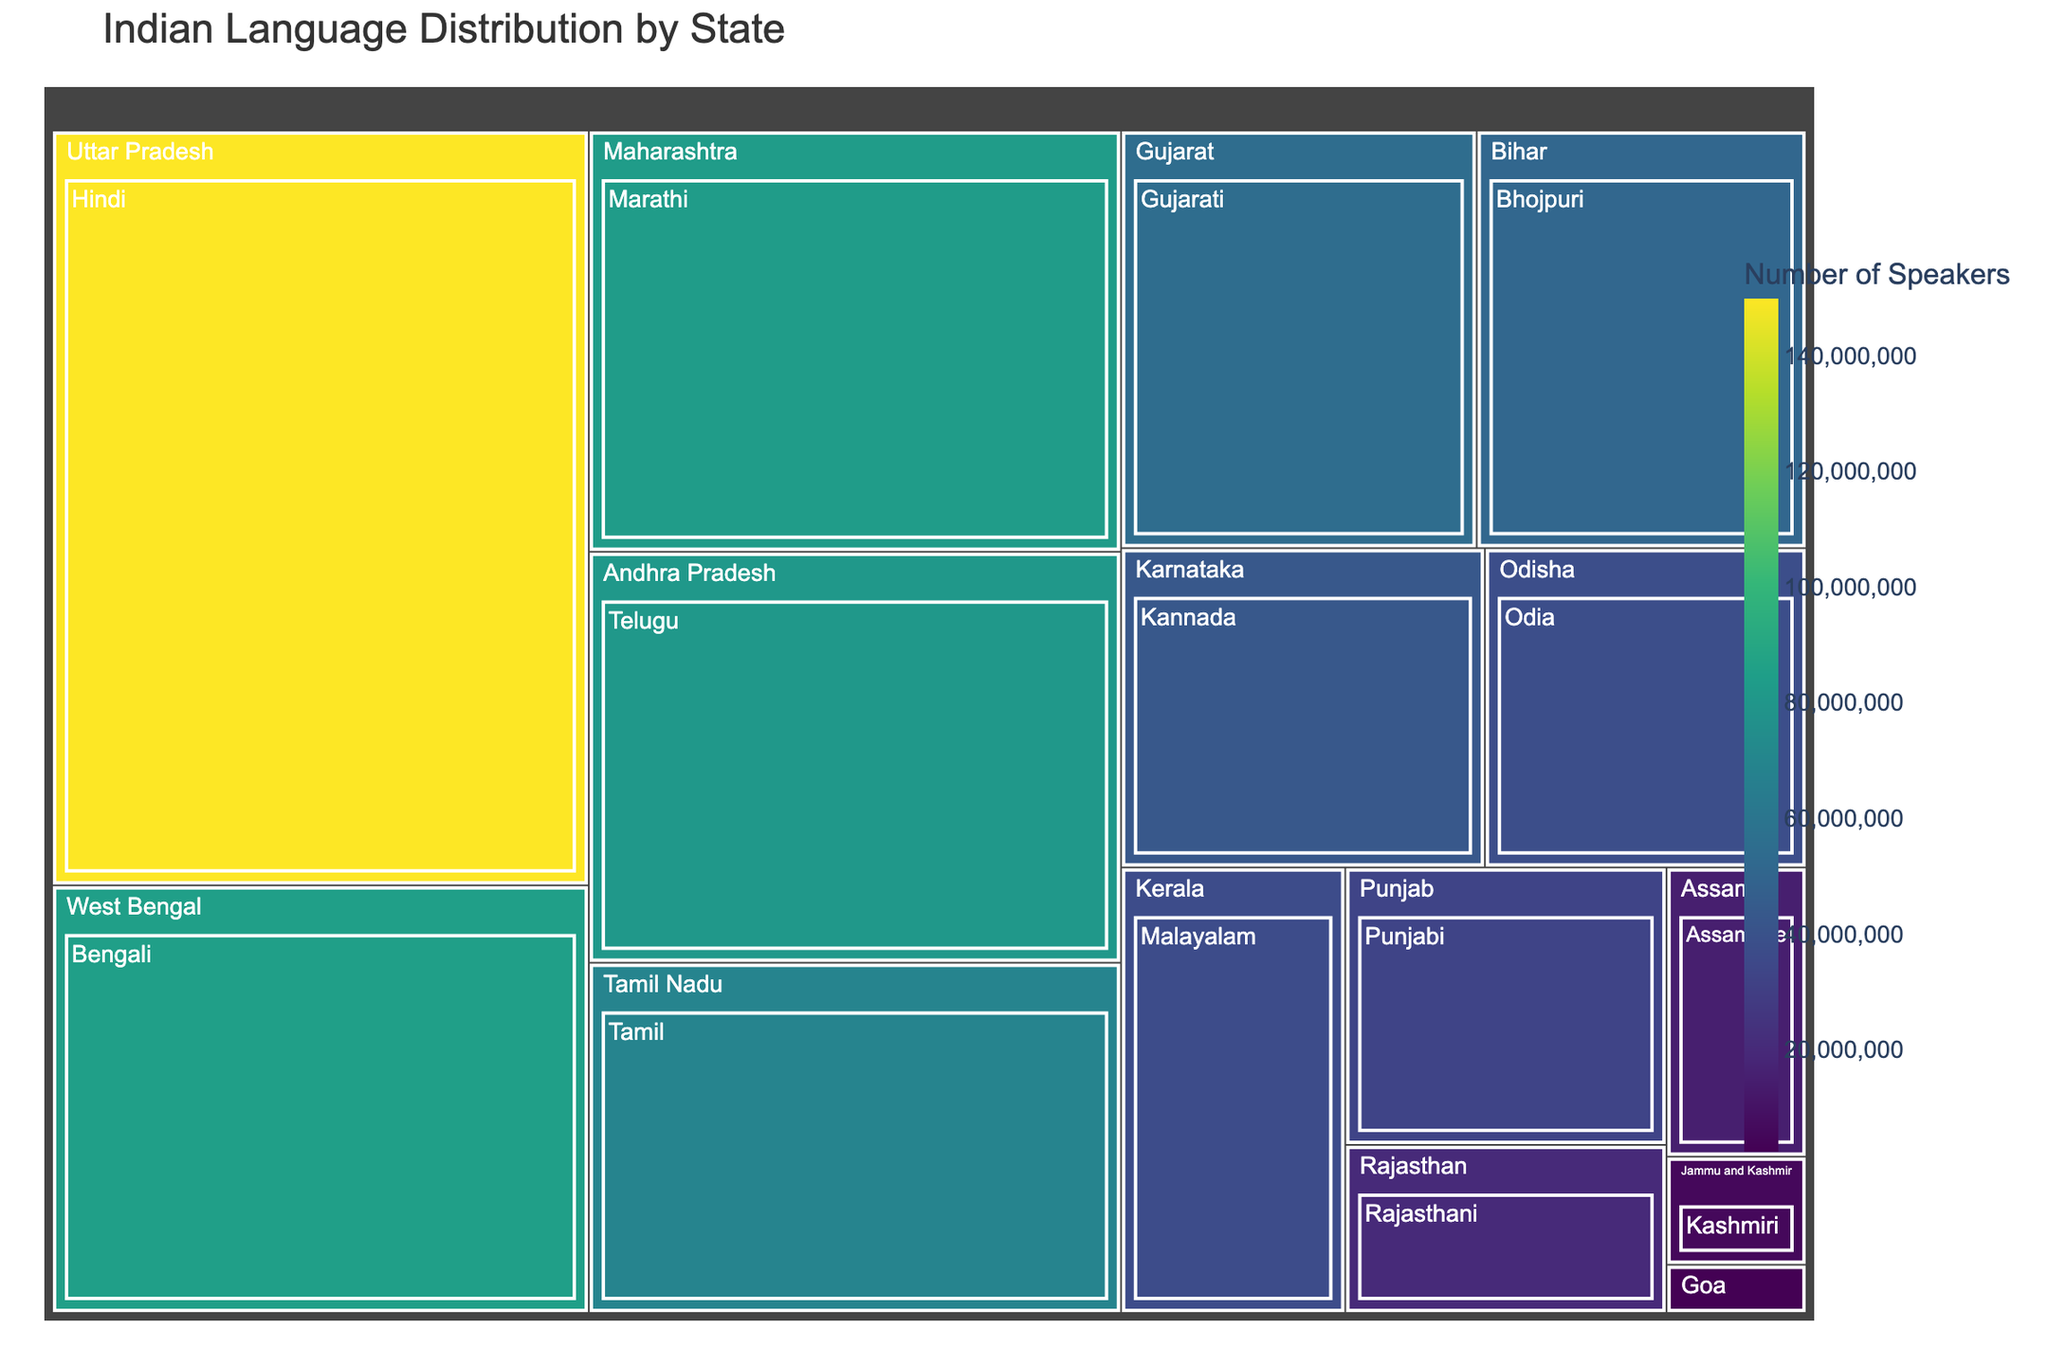What's the title of the Treemap? The title of the Treemap is typically displayed at the top and summarizes the main topic of the visualization. In this case, it shows "Indian Language Distribution by State".
Answer: Indian Language Distribution by State Which state has the highest number of Hindi speakers? From the Treemap, we observe that states' labels and their respective language speakers are visually displayed. The state with the highest number of Hindi speakers is Uttar Pradesh with 150,000,000 speakers.
Answer: Uttar Pradesh How many speakers of Konkani are there in Goa? To identify the number of speakers of Konkani in Goa, locate the section labeled "Goa - Konkani" which indicates the number of speakers. The figure shows 2,500,000 speakers.
Answer: 2,500,000 Which state has a higher number of speakers: Gujarat or Bihar? By comparing the sections labeled "Gujarat - Gujarati" and "Bihar - Bhojpuri", we can see that Gujarat has 55,000,000 speakers while Bihar has 51,000,000 speakers. Thus, Gujarat has a higher number.
Answer: Gujarat What is the combined number of speakers in West Bengal and Tamil Nadu? West Bengal has 85,000,000 Bengali speakers and Tamil Nadu has 69,000,000 Tamil speakers. To find the combined number, sum these values: 85,000,000 + 69,000,000 = 154,000,000.
Answer: 154,000,000 Which Indian language has the least number of speakers and in which state is it spoken? Finding the smallest section reveals that Kashmiri in Jammu and Kashmir has the least number of speakers, totaling 5,600,000.
Answer: Kashmiri, Jammu and Kashmir Compare the number of speakers in Maharashtra (Marathi) and Karnataka (Kannada). Which state has more speakers? Maharashtra with Marathi speakers totals 83,000,000, while Karnataka with Kannada speakers totals 43,000,000. Thus, Maharashtra has more speakers.
Answer: Maharashtra What is the total number of speakers for the languages spoken in South Indian states? South Indian states in the Treemap include Tamil Nadu (Tamil - 69,000,000), Karnataka (Kannada - 43,000,000), Andhra Pradesh (Telugu - 81,000,000), and Kerala (Malayalam - 37,000,000). Summing these values: 69,000,000 + 43,000,000 + 81,000,000 + 37,000,000 = 230,000,000.
Answer: 230,000,000 How does the number of Punjabi speakers in Punjab compare to the number of Odia speakers in Odisha? Punjab has 33,000,000 Punjabi speakers and Odisha has 38,000,000 Odia speakers. Odisha has more Odia speakers compared to Punjabi speakers in Punjab.
Answer: Odisha has more Which has fewer speakers: Assamese in Assam or Rajasthani in Rajasthan? On the Treemap, Assamese speakers in Assam total 15,000,000 while Rajasthani speakers in Rajasthan total 20,000,000. Thus, Assamese in Assam has fewer speakers.
Answer: Assamese in Assam 